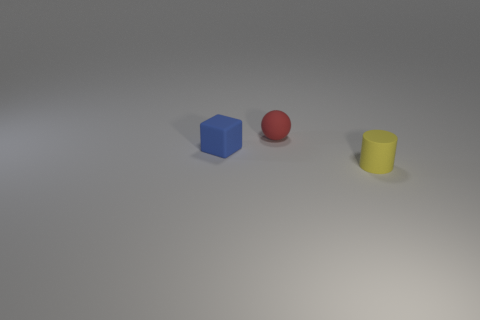Add 3 tiny things. How many objects exist? 6 Subtract all cylinders. How many objects are left? 2 Add 2 cylinders. How many cylinders are left? 3 Add 3 small red things. How many small red things exist? 4 Subtract 1 red spheres. How many objects are left? 2 Subtract all purple blocks. Subtract all brown cylinders. How many blocks are left? 1 Subtract all purple spheres. How many gray cylinders are left? 0 Subtract all tiny gray balls. Subtract all cylinders. How many objects are left? 2 